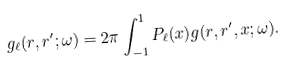<formula> <loc_0><loc_0><loc_500><loc_500>g _ { \ell } ( r , r ^ { \prime } ; \omega ) = 2 \pi \int _ { - 1 } ^ { 1 } P _ { \ell } ( x ) g ( r , r ^ { \prime } , x ; \omega ) .</formula> 